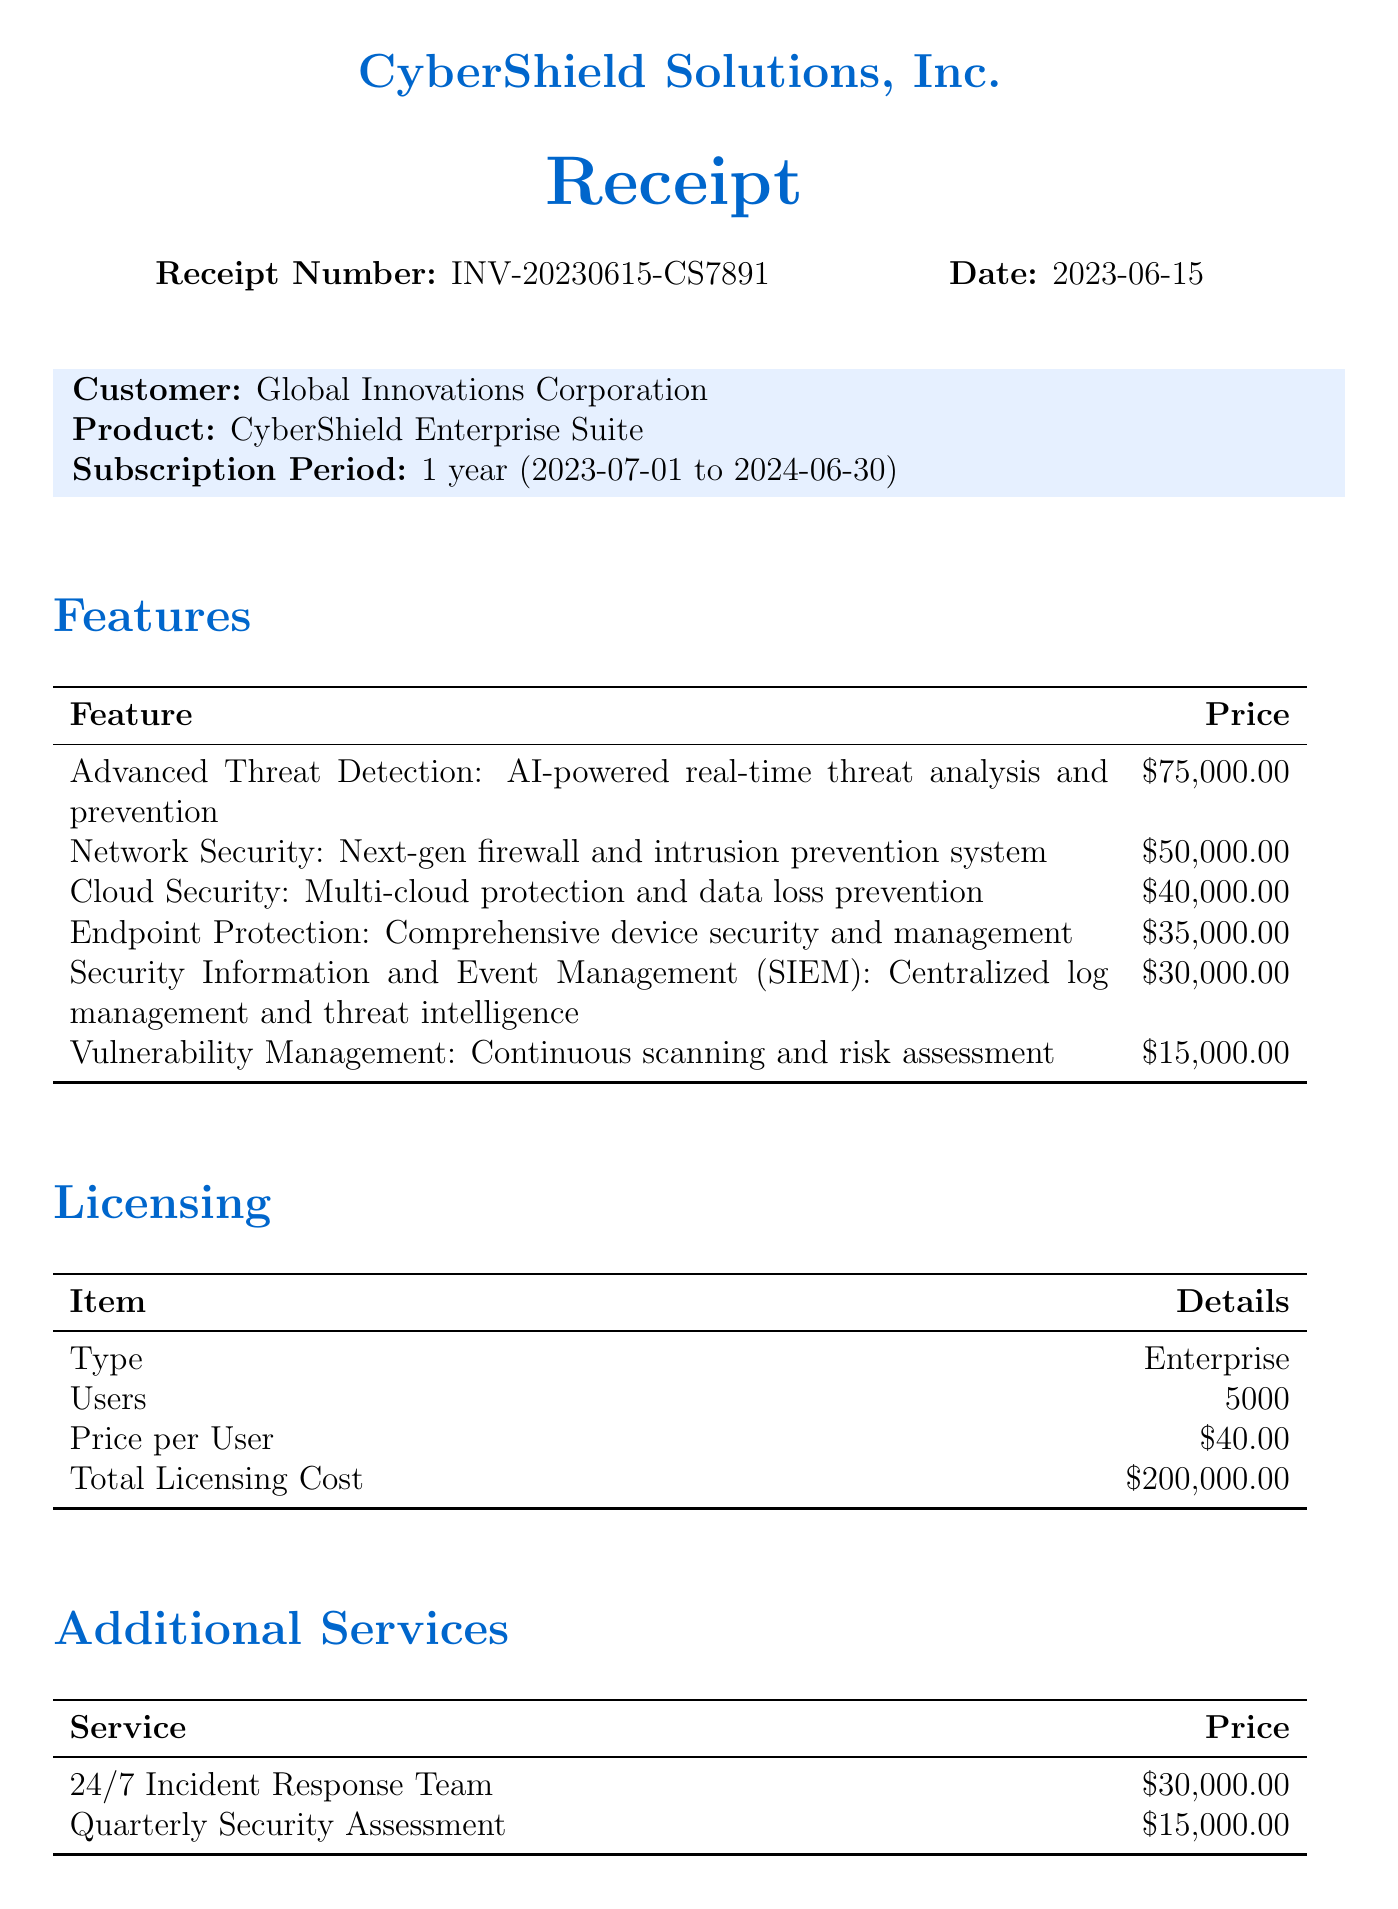What is the receipt number? The receipt number is mentioned at the top of the document, identifying this specific transaction.
Answer: INV-20230615-CS7891 What is the total amount for the subscription? The total amount is displayed in the payment summary section at the end of the document.
Answer: $245,000.00 How many users are included in the licensing? The number of users is specified in the licensing section of the document.
Answer: 5000 What feature costs the most? The features listed in the document each have a price, and the one with the highest price is the most expensive.
Answer: Advanced Threat Detection What is the price per user for the software? The price per user is provided in the licensing information, specifically the cost associated with each user.
Answer: $40.00 What is the subscription end date? This is explicitly stated in the subscription details found in the document.
Answer: 2024-06-30 What additional service costs $15,000.00? The document includes a list of additional services with their respective costs, making identifying this specific service possible.
Answer: Quarterly Security Assessment Is tax included in the total amount? The tax amount is mentioned in the payment summary, indicating whether it contributes to the total.
Answer: $0.00 What is the contact email for the sales representative? The contact information section provides email details for reaching the sales representative.
Answer: sarah.johnson@cybershield.com 